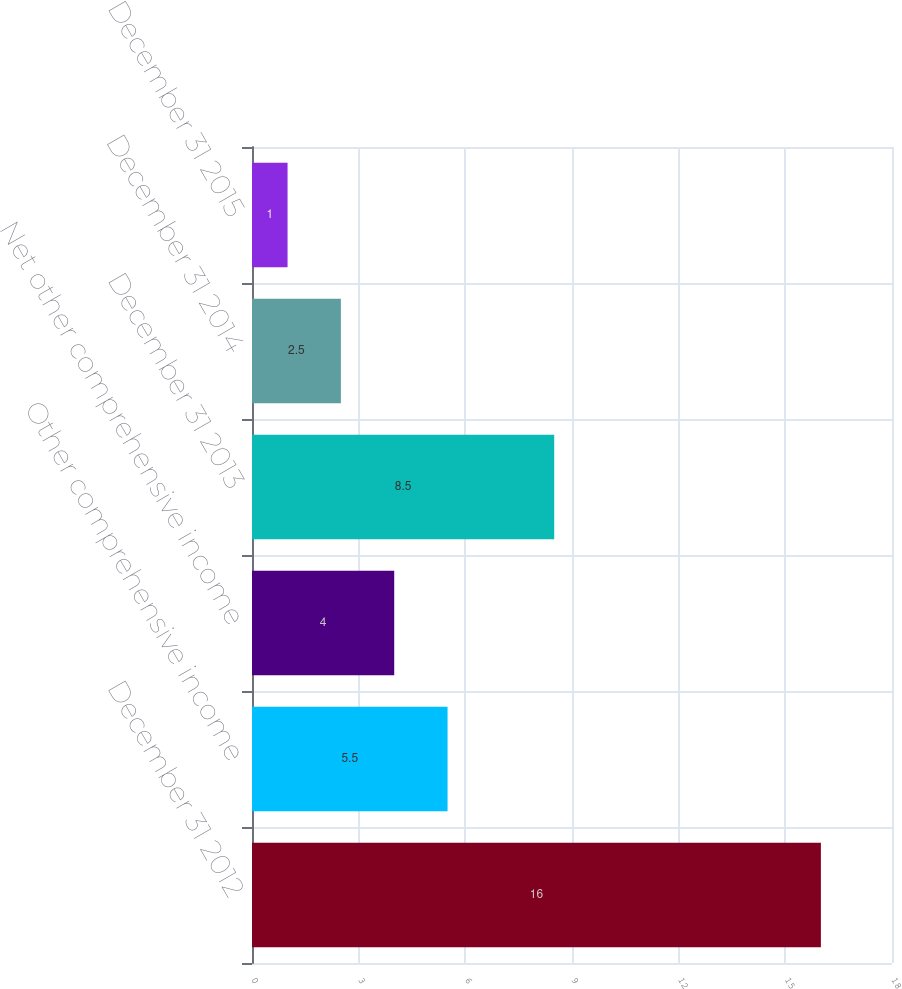Convert chart. <chart><loc_0><loc_0><loc_500><loc_500><bar_chart><fcel>December 31 2012<fcel>Other comprehensive income<fcel>Net other comprehensive income<fcel>December 31 2013<fcel>December 31 2014<fcel>December 31 2015<nl><fcel>16<fcel>5.5<fcel>4<fcel>8.5<fcel>2.5<fcel>1<nl></chart> 